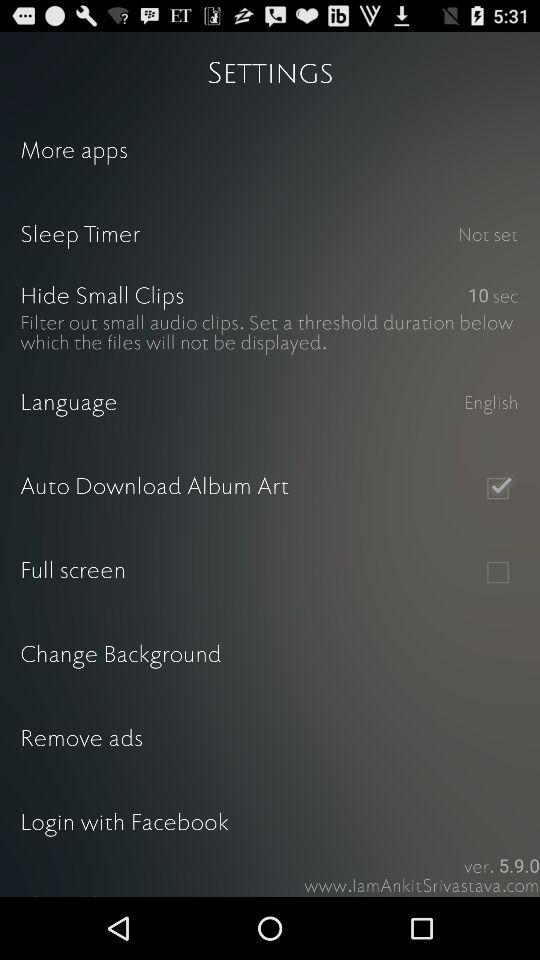What is the status of "Auto Download Album Art"? The status of "Auto Download Album Art" is "on". 